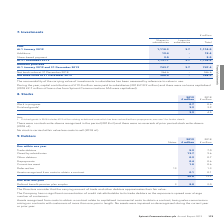According to Spirent Communications Plc's financial document, What does finished goods in 2018 include? £2.2 million relating to deferred costs which has been reclassified from prepayments. The document states: "Note 1. Finished goods in 2018 includes £2.2 million relating to deferred costs which has been reclassified from prepayments; see note 1 for further d..." Also, Was there any stock write-downs recognised in the period? There were no stock write-downs recognised in the period. The document states: "There were no stock write-downs recognised in the period (2018 nil) and there were no reversals of prior period stock write-downs (2018 nil)...." Also, What are the types of stocks in the table? The document shows two values: Work in progress and Finished goods. From the document: "Finished goods¹ 3.2 3.9 Work in progress 0.7 0.6..." Additionally, In which year was the amount of work in progress larger? According to the financial document, 2019. The relevant text states: "179 Spirent Communications plc Annual Report 2019..." Also, can you calculate: What was the change in the amount of stocks? Based on the calculation: 3.9-4.5, the result is -0.6 (in millions). This is based on the information: "3.9 4.5 3.9 4.5..." The key data points involved are: 3.9, 4.5. Also, can you calculate: What was the percentage change in the amount of stocks? To answer this question, I need to perform calculations using the financial data. The calculation is: (3.9-4.5)/4.5, which equals -13.33 (percentage). This is based on the information: "3.9 4.5 3.9 4.5..." The key data points involved are: 3.9, 4.5. 